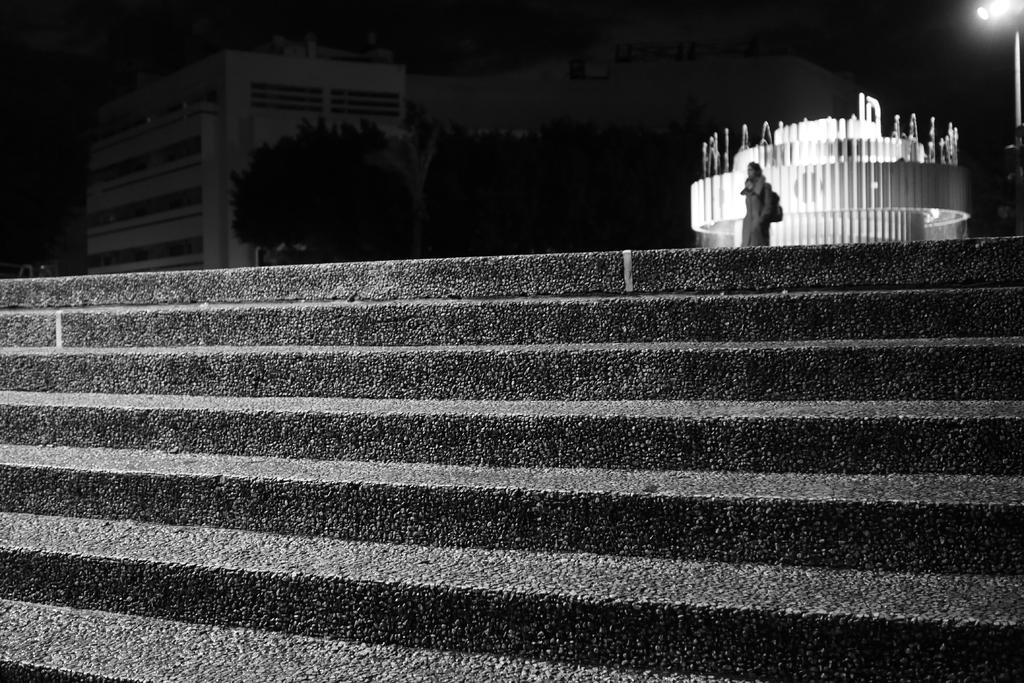What can be seen in the image that allows people to move between different levels? There are stairs in the image. What type of structure is visible in the background of the image? There is a building in the background of the image. What book is being read by the person standing at the top of the stairs in the image? There is no person or book visible in the image; it only features stairs and a building in the background. 